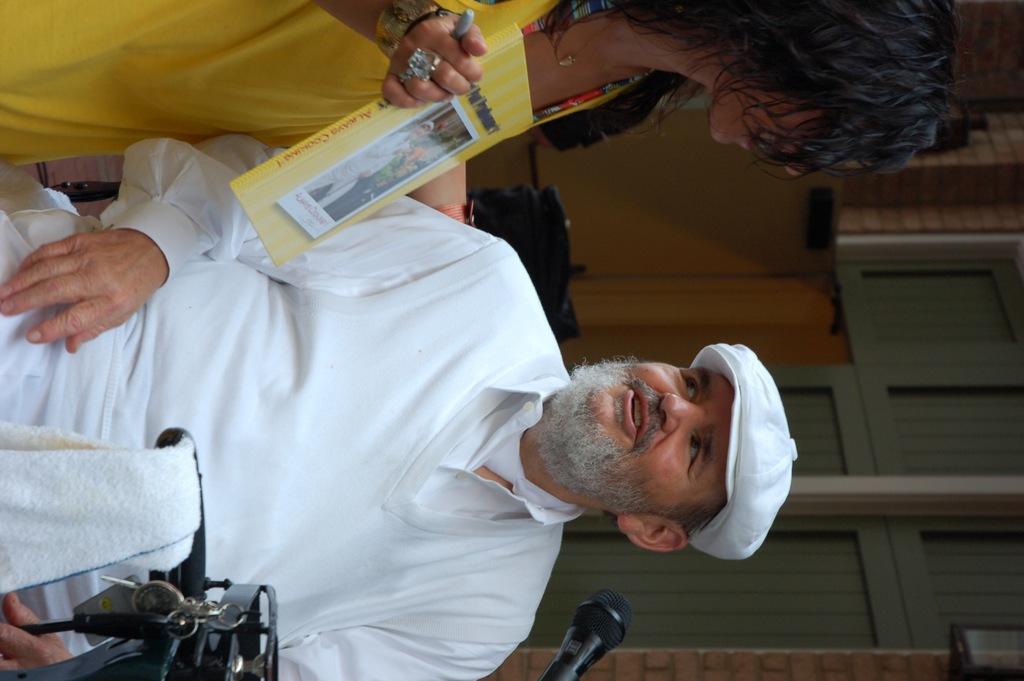In one or two sentences, can you explain what this image depicts? In the image we can see a man and a woman wearing clothes and the man is wearing a cap. This is a book, napkin, microphone, finger ring, neck chain, bracelet and a wall. 